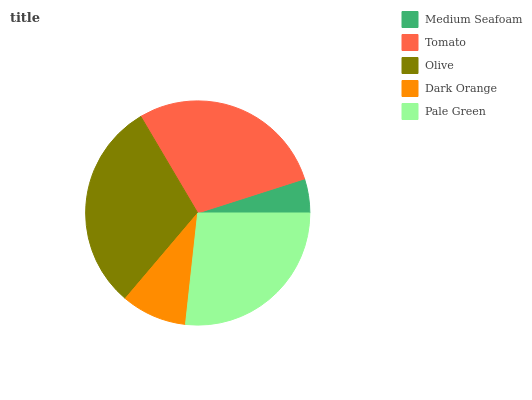Is Medium Seafoam the minimum?
Answer yes or no. Yes. Is Olive the maximum?
Answer yes or no. Yes. Is Tomato the minimum?
Answer yes or no. No. Is Tomato the maximum?
Answer yes or no. No. Is Tomato greater than Medium Seafoam?
Answer yes or no. Yes. Is Medium Seafoam less than Tomato?
Answer yes or no. Yes. Is Medium Seafoam greater than Tomato?
Answer yes or no. No. Is Tomato less than Medium Seafoam?
Answer yes or no. No. Is Pale Green the high median?
Answer yes or no. Yes. Is Pale Green the low median?
Answer yes or no. Yes. Is Medium Seafoam the high median?
Answer yes or no. No. Is Medium Seafoam the low median?
Answer yes or no. No. 